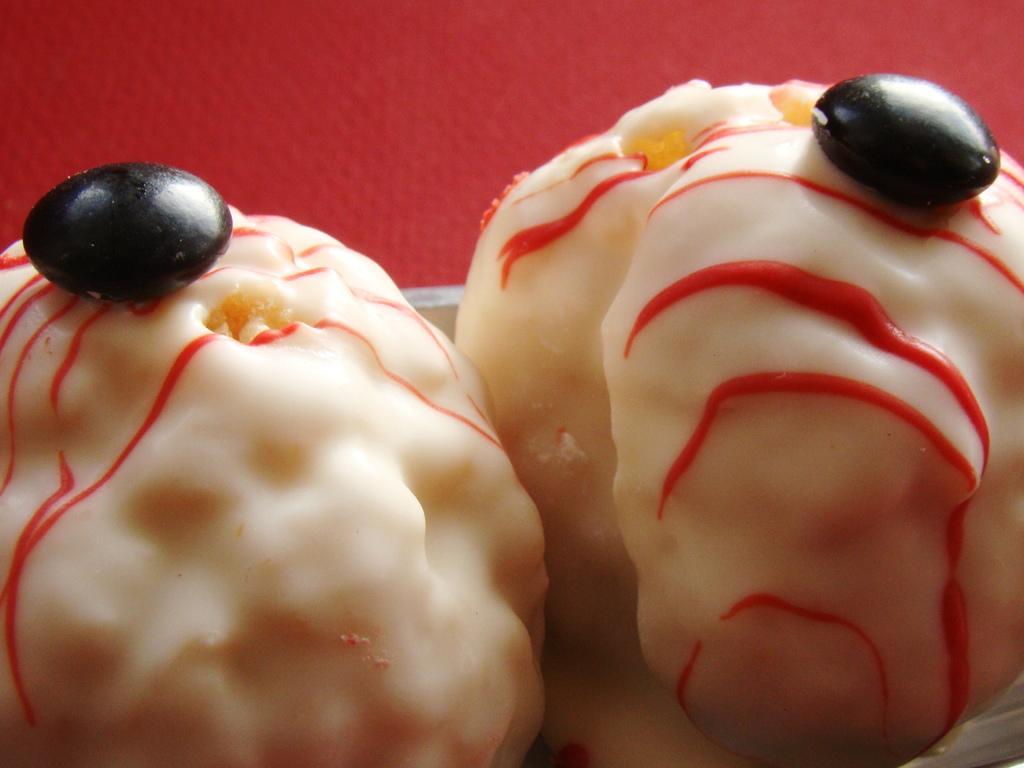How would you summarize this image in a sentence or two? In the center of the image we can see some food item. And we can see the red colored background. 